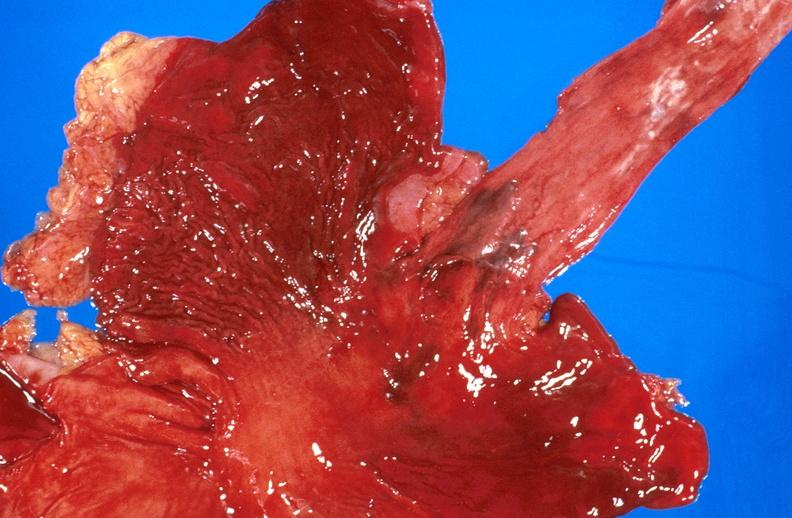why does this image show esophageal varices?
Answer the question using a single word or phrase. Due to alcoholic cirrhosis 